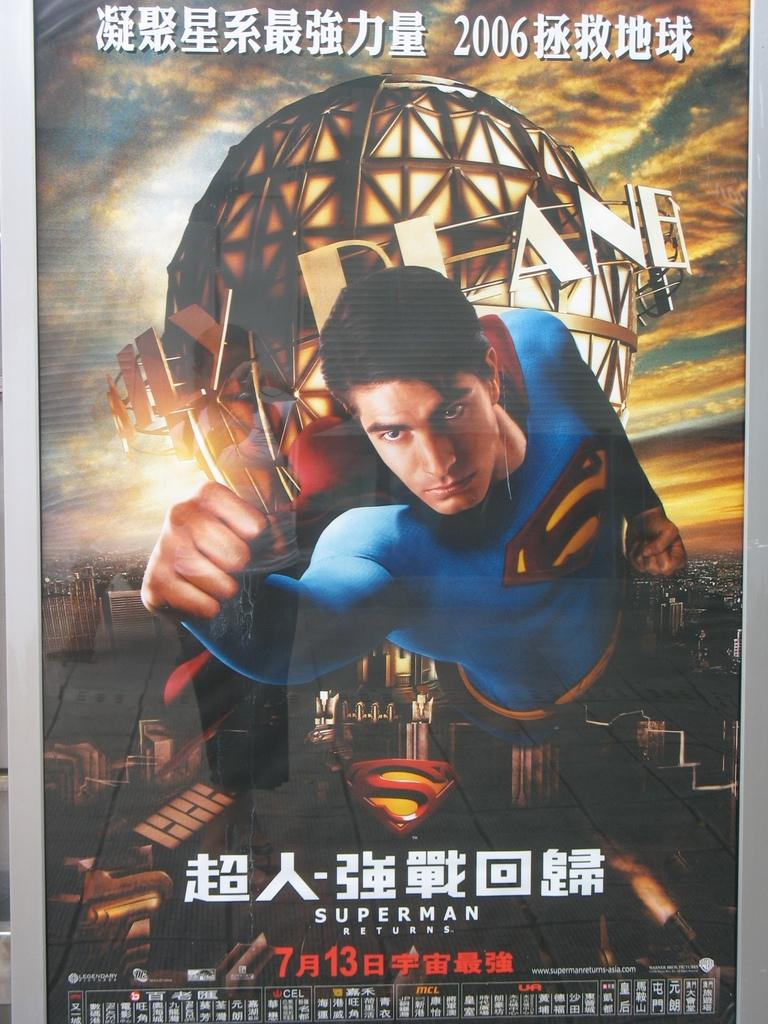Provide a one-sentence caption for the provided image. A foreign language poster for the 2006 movie Superman Returns. 